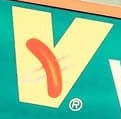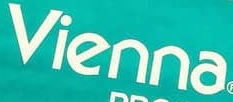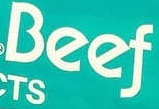What text appears in these images from left to right, separated by a semicolon? v; vienna; Beef 